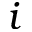Convert formula to latex. <formula><loc_0><loc_0><loc_500><loc_500>i</formula> 